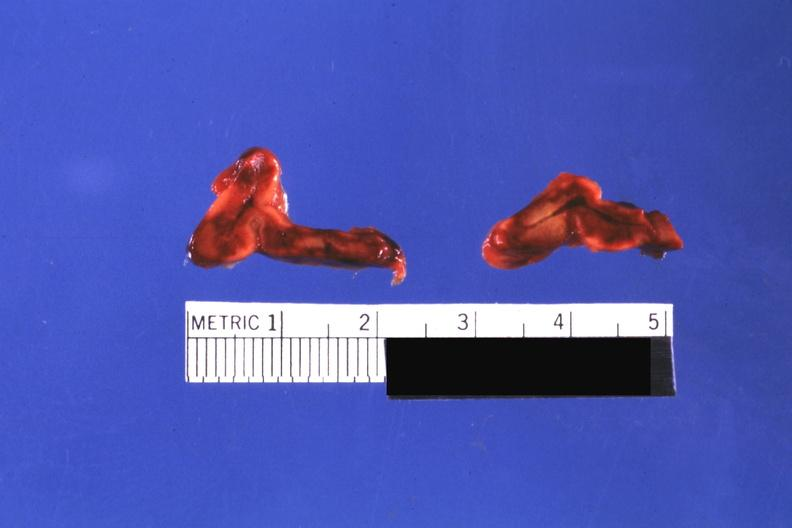does cut surfaces of both adrenals focal hemorrhagic infarction well shown do not know history look like placental abruption?
Answer the question using a single word or phrase. Yes 